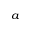<formula> <loc_0><loc_0><loc_500><loc_500>^ { a }</formula> 